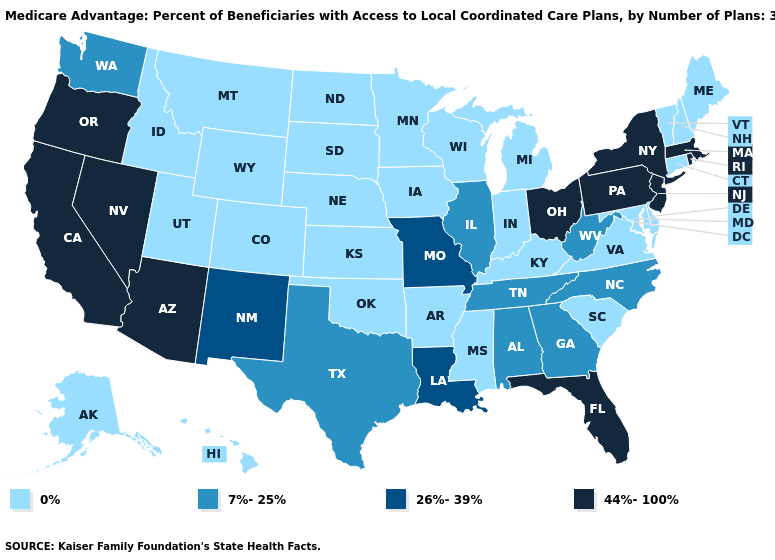Does Vermont have the lowest value in the USA?
Give a very brief answer. Yes. What is the value of Texas?
Quick response, please. 7%-25%. Which states have the lowest value in the USA?
Concise answer only. Alaska, Arkansas, Colorado, Connecticut, Delaware, Hawaii, Iowa, Idaho, Indiana, Kansas, Kentucky, Maryland, Maine, Michigan, Minnesota, Mississippi, Montana, North Dakota, Nebraska, New Hampshire, Oklahoma, South Carolina, South Dakota, Utah, Virginia, Vermont, Wisconsin, Wyoming. Name the states that have a value in the range 44%-100%?
Concise answer only. Arizona, California, Florida, Massachusetts, New Jersey, Nevada, New York, Ohio, Oregon, Pennsylvania, Rhode Island. What is the highest value in the MidWest ?
Keep it brief. 44%-100%. What is the value of Indiana?
Give a very brief answer. 0%. What is the value of New Jersey?
Concise answer only. 44%-100%. What is the value of Rhode Island?
Concise answer only. 44%-100%. Name the states that have a value in the range 44%-100%?
Quick response, please. Arizona, California, Florida, Massachusetts, New Jersey, Nevada, New York, Ohio, Oregon, Pennsylvania, Rhode Island. What is the value of Illinois?
Short answer required. 7%-25%. Name the states that have a value in the range 0%?
Quick response, please. Alaska, Arkansas, Colorado, Connecticut, Delaware, Hawaii, Iowa, Idaho, Indiana, Kansas, Kentucky, Maryland, Maine, Michigan, Minnesota, Mississippi, Montana, North Dakota, Nebraska, New Hampshire, Oklahoma, South Carolina, South Dakota, Utah, Virginia, Vermont, Wisconsin, Wyoming. What is the value of Pennsylvania?
Answer briefly. 44%-100%. Does Wisconsin have the highest value in the USA?
Concise answer only. No. What is the value of Missouri?
Answer briefly. 26%-39%. What is the value of Pennsylvania?
Concise answer only. 44%-100%. 